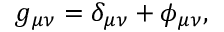<formula> <loc_0><loc_0><loc_500><loc_500>g _ { \mu \nu } = \delta _ { \mu \nu } + \phi _ { \mu \nu } ,</formula> 